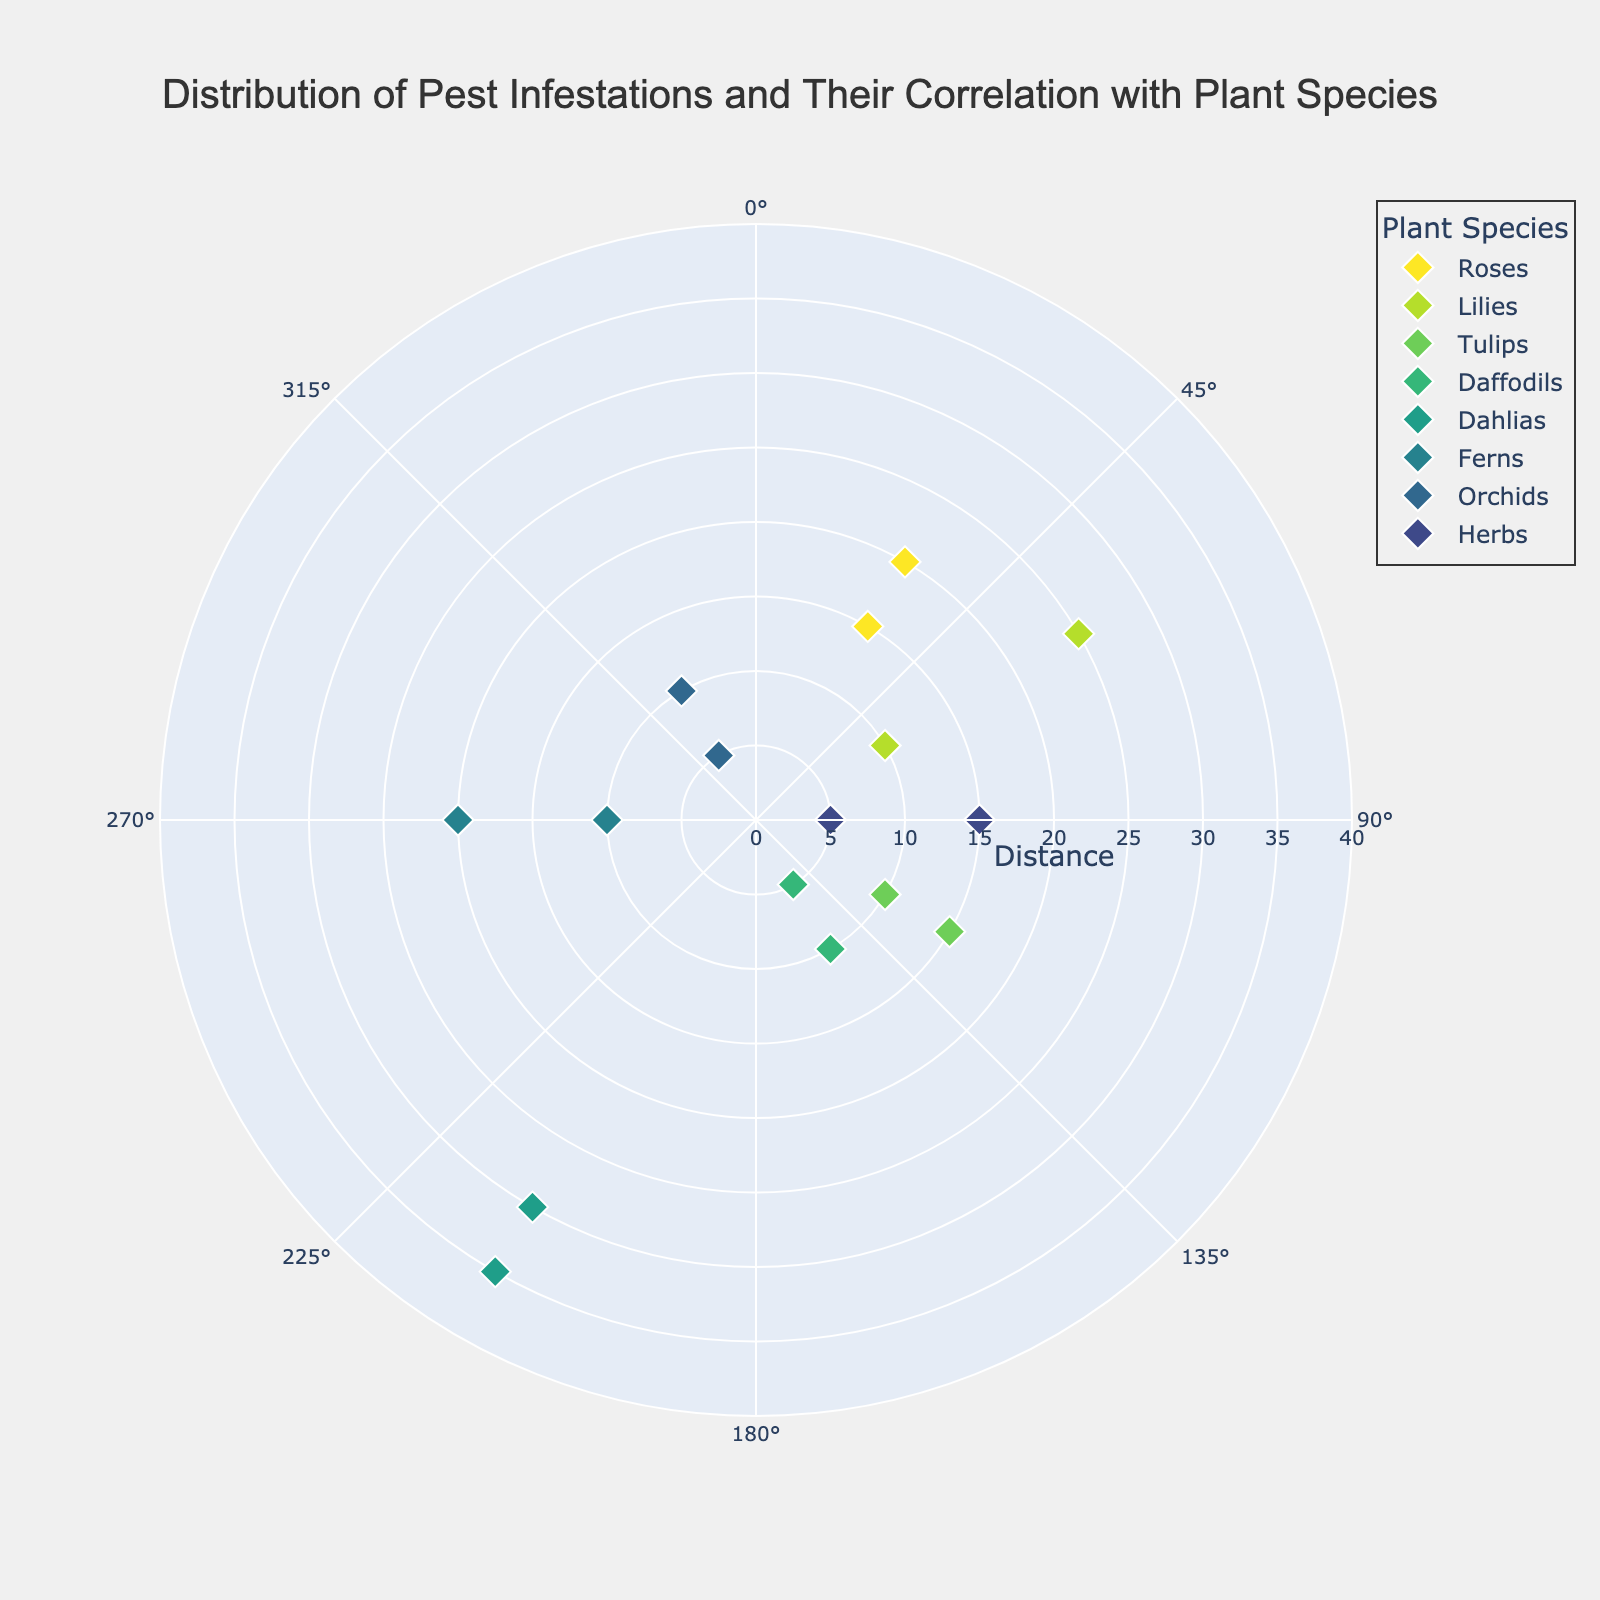What's the title of the figure? The title of the figure is located at the top and it reads "Distribution of Pest Infestations and Their Correlation with Plant Species".
Answer: Distribution of Pest Infestations and Their Correlation with Plant Species What plant species has the maximum distance infested by pests? The plant species with the maximum distance infested by pests can be found by looking at the point farthest from the center. The "Dahlias" have a distance of 35 units, which is the maximum.
Answer: Dahlias How many data points are shown for the "Lilies"? By observing the legend and the corresponding data points on the plot, the "Lilies" have points at angles 60° with distances 10 and 25 respectively, giving a total of two data points.
Answer: 2 Which plant species have pest infestations at an angle of 90 degrees? By checking the angle 90° on the angular axis, the pest infestations at this angle belong to the "Herbs".
Answer: Herbs What's the average distance of pest infestations for the "Roses"? To find the average distance for the "Roses," sum the distances (15 + 20) and divide by the number of data points. Average distance = (15 + 20) / 2 = 17.5.
Answer: 17.5 Which two plant species have pest infestations closest to the center? By locating the points nearest to the center (smallest distance), "Daffodils" and "Orchids" have points at 5 units distance.
Answer: Daffodils and Orchids Between "Tulips" and "Ferns", which has a greater range of pest infestation distances? "Tulips" have distances 10 and 15, which gives a range of 15 - 10 = 5. "Ferns" have distances 10 and 20, giving a range of 20 - 10 = 10. Comparing both, "Ferns" have the greater range.
Answer: Ferns What is the overall range of distances for pest infestations in the garden? The overall range is determined by the minimum and maximum distances in the data. Minimum distance is 5 (from "Daffodils" and "Orchids") and maximum distance is 35 (from "Dahlias"). Thus, the range is 35 - 5 = 30.
Answer: 30 What plant species appear at an angle of 330 degrees and what is their range of distances? By looking at the 330° angle, "Orchids" appear with distances of 5 and 10. The range is calculated as 10 - 5 = 5.
Answer: Orchids and 5 